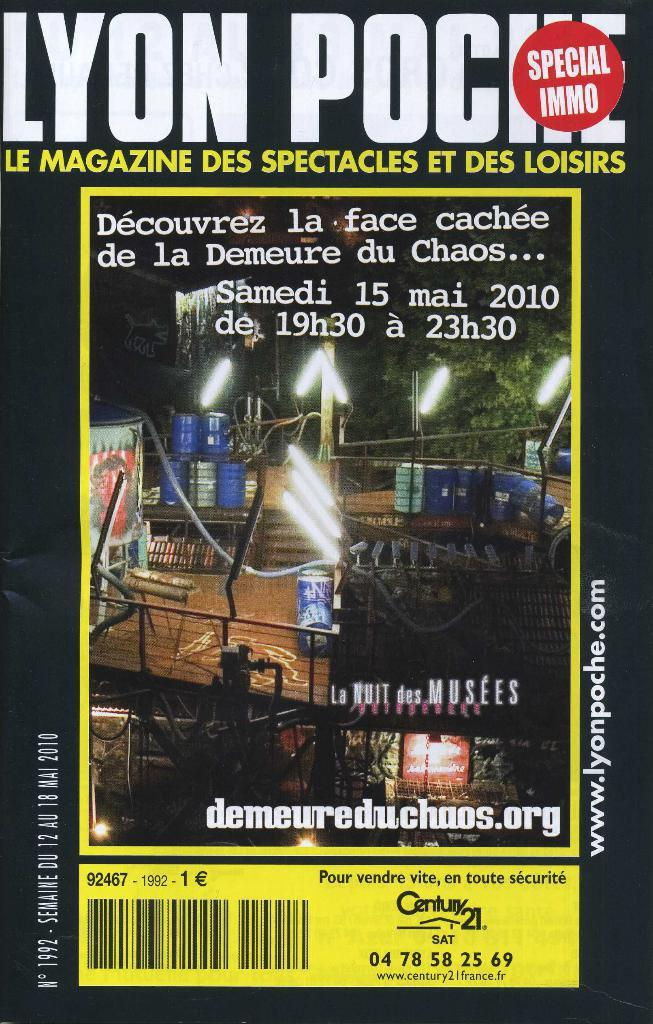<image>
Present a compact description of the photo's key features. A magazine cover that is sponsored by Century 21. 